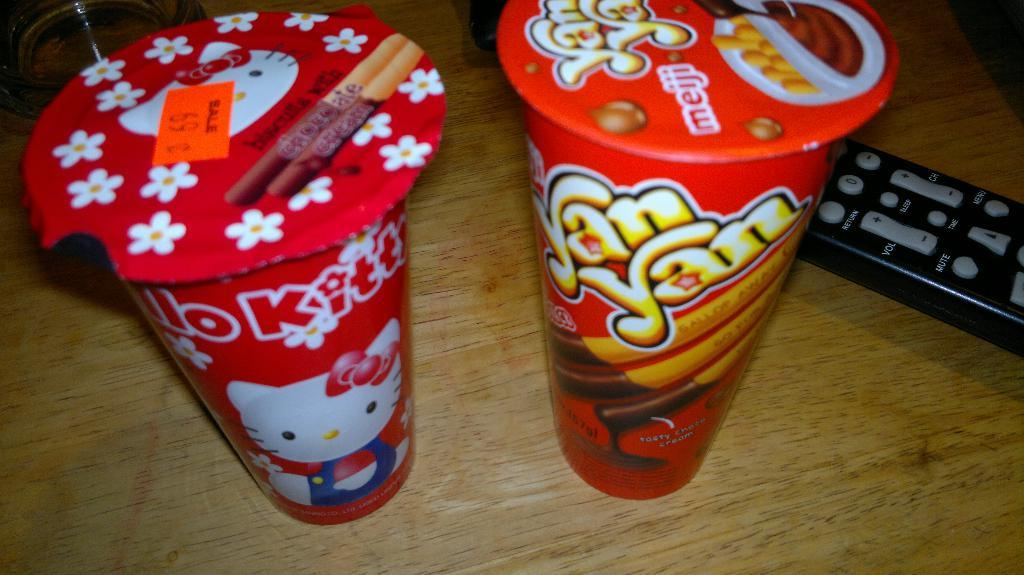<image>
Summarize the visual content of the image. A package of Hello Kitty biscuits sitting next to a package of YanYans made by Meiji. 